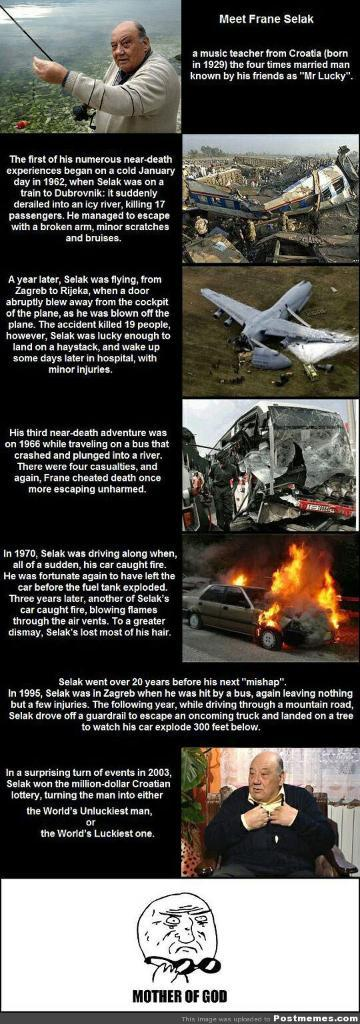<image>
Share a concise interpretation of the image provided. A humorous article about a man named Frane Selak, also known as Mr Lucky. 